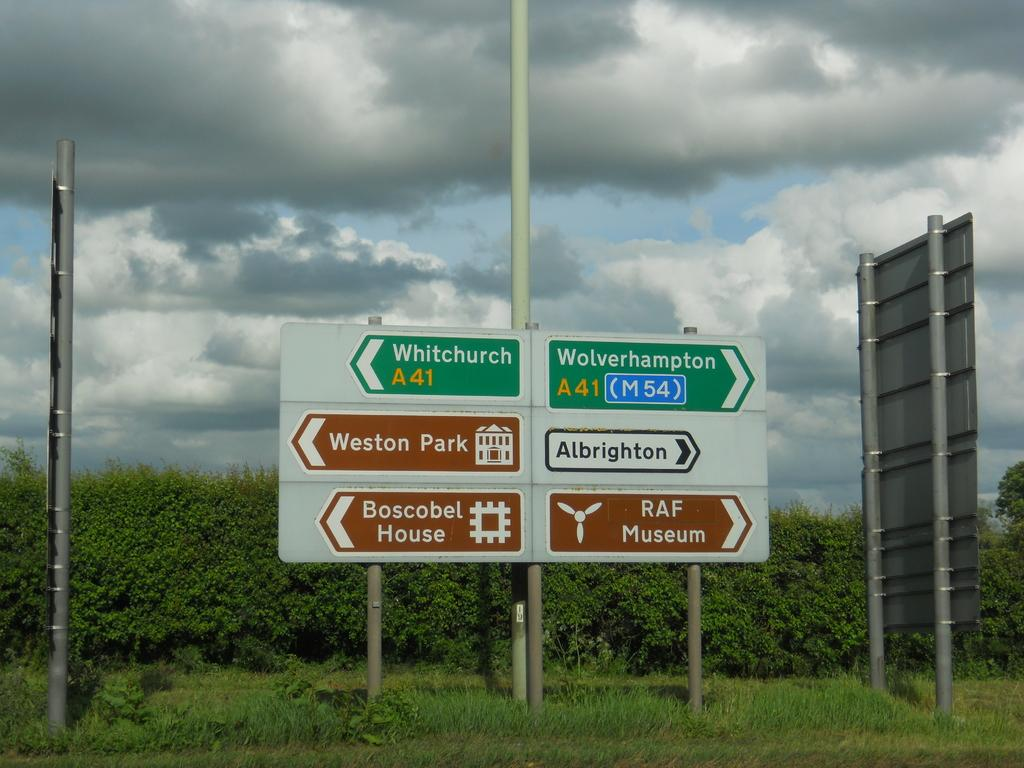Provide a one-sentence caption for the provided image. A green sign for Whitechurch A 41 points to the west towards Weston Park. 